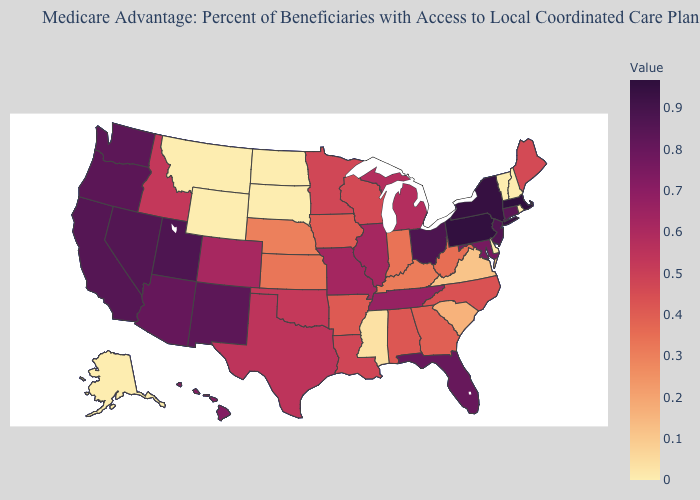Which states have the lowest value in the USA?
Give a very brief answer. Alaska, Delaware, Montana, North Dakota, New Hampshire, Rhode Island, South Dakota, Vermont, Wyoming. Among the states that border Oregon , which have the highest value?
Keep it brief. Nevada. Is the legend a continuous bar?
Quick response, please. Yes. 